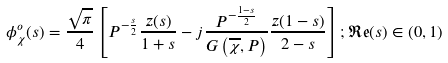Convert formula to latex. <formula><loc_0><loc_0><loc_500><loc_500>\phi _ { \chi } ^ { o } ( s ) = \frac { \sqrt { \pi } } { 4 } \left [ P ^ { - \frac { s } { 2 } } \frac { z ( s ) } { 1 + s } - j \frac { P ^ { - \frac { 1 - s } { 2 } } } { G \left ( \overline { \chi } , P \right ) } \frac { z ( 1 - s ) } { 2 - s } \right ] ; \mathfrak { R e } ( s ) \in ( 0 , 1 )</formula> 